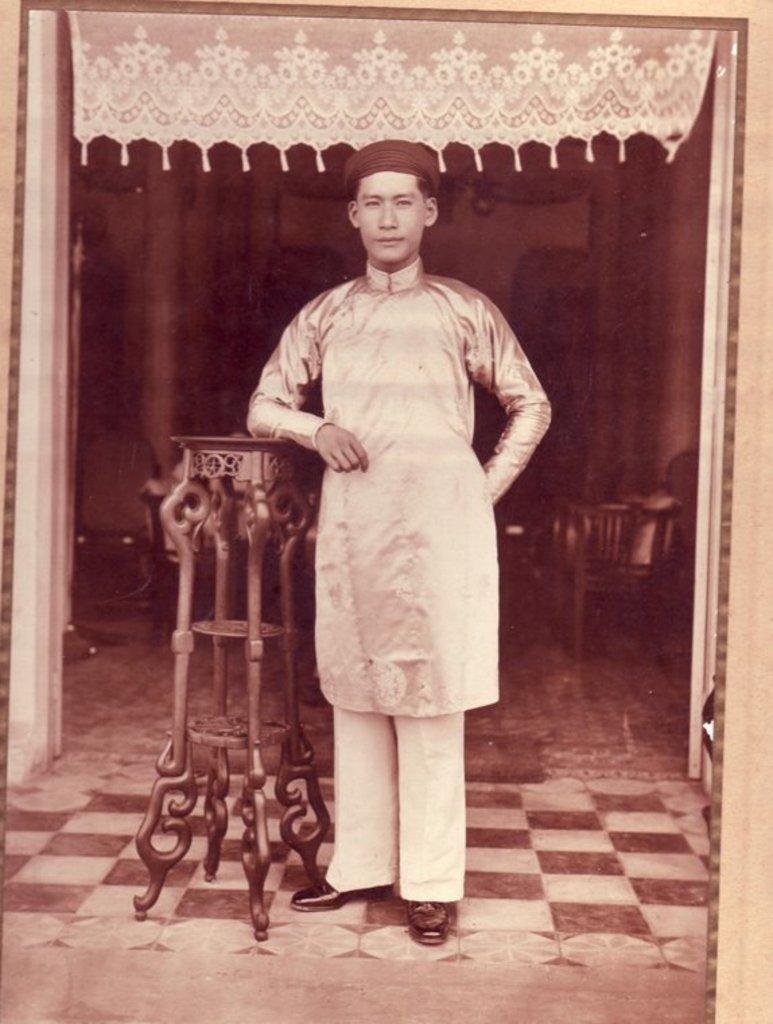Could you give a brief overview of what you see in this image? In this image I can see a man who is standing in front and I can see he is wearing a cap and I see a stand near to him. In the background I can see a chair and on the top of this picture I can see a cloth on which there are designs. 